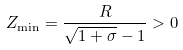<formula> <loc_0><loc_0><loc_500><loc_500>Z _ { \min } = \frac { R } { \sqrt { 1 + \sigma } - 1 } > 0</formula> 